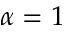Convert formula to latex. <formula><loc_0><loc_0><loc_500><loc_500>\alpha = 1</formula> 